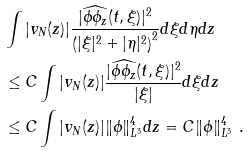Convert formula to latex. <formula><loc_0><loc_0><loc_500><loc_500>& \int | v _ { N } ( z ) | \frac { | \widehat { \phi \phi _ { z } } ( t , \xi ) | ^ { 2 } } { \left ( | \xi | ^ { 2 } + | \eta | ^ { 2 } \right ) ^ { 2 } } d \xi d \eta d z \\ & \leq C \int | v _ { N } ( z ) | \frac { | \widehat { \phi \phi _ { z } } ( t , \xi ) | ^ { 2 } } { | \xi | } d \xi d z \\ & \leq C \int | v _ { N } ( z ) | \| \phi \| ^ { 4 } _ { L ^ { 3 } } d z = C \| \phi \| ^ { 4 } _ { L ^ { 3 } } \ .</formula> 